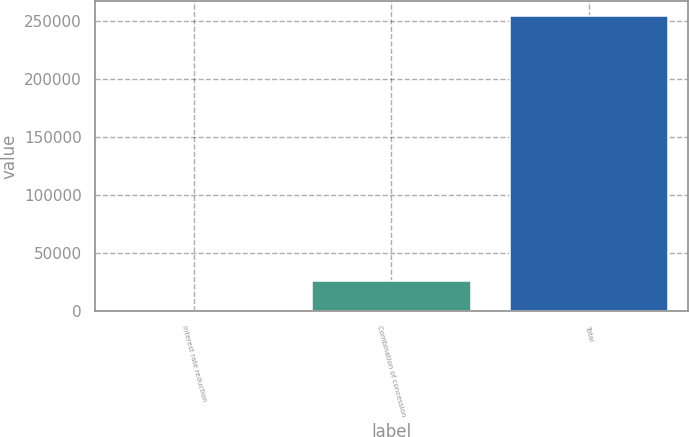Convert chart to OTSL. <chart><loc_0><loc_0><loc_500><loc_500><bar_chart><fcel>Interest rate reduction<fcel>Combination of concession<fcel>Total<nl><fcel>335<fcel>25736.7<fcel>254352<nl></chart> 